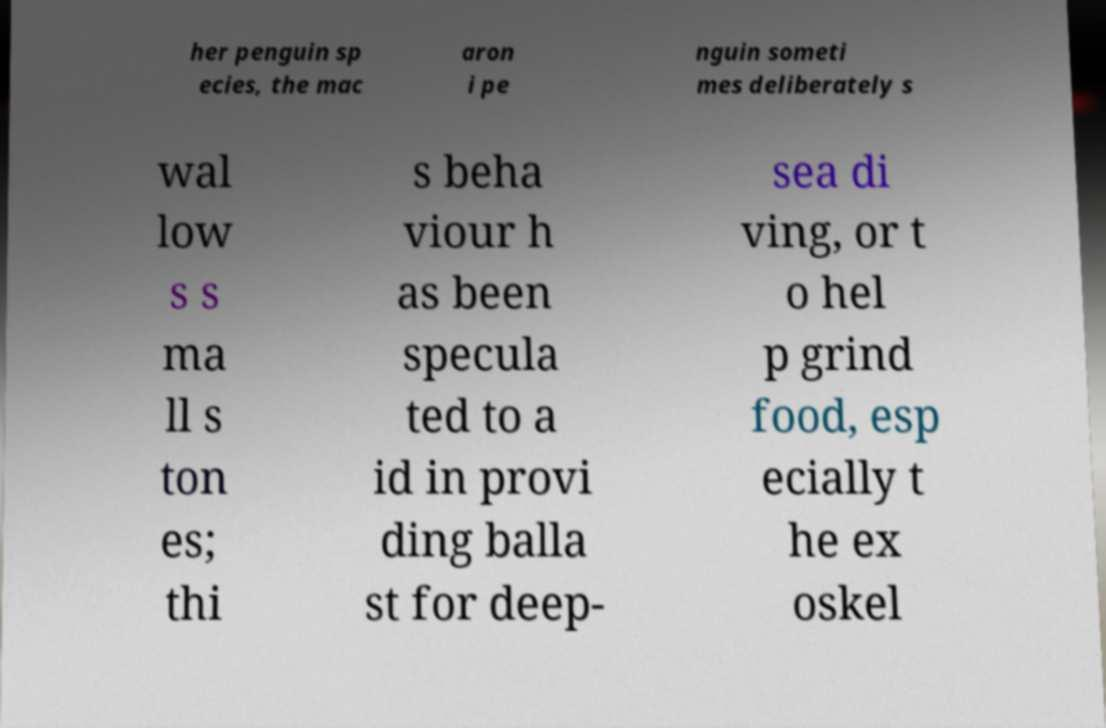Could you extract and type out the text from this image? her penguin sp ecies, the mac aron i pe nguin someti mes deliberately s wal low s s ma ll s ton es; thi s beha viour h as been specula ted to a id in provi ding balla st for deep- sea di ving, or t o hel p grind food, esp ecially t he ex oskel 